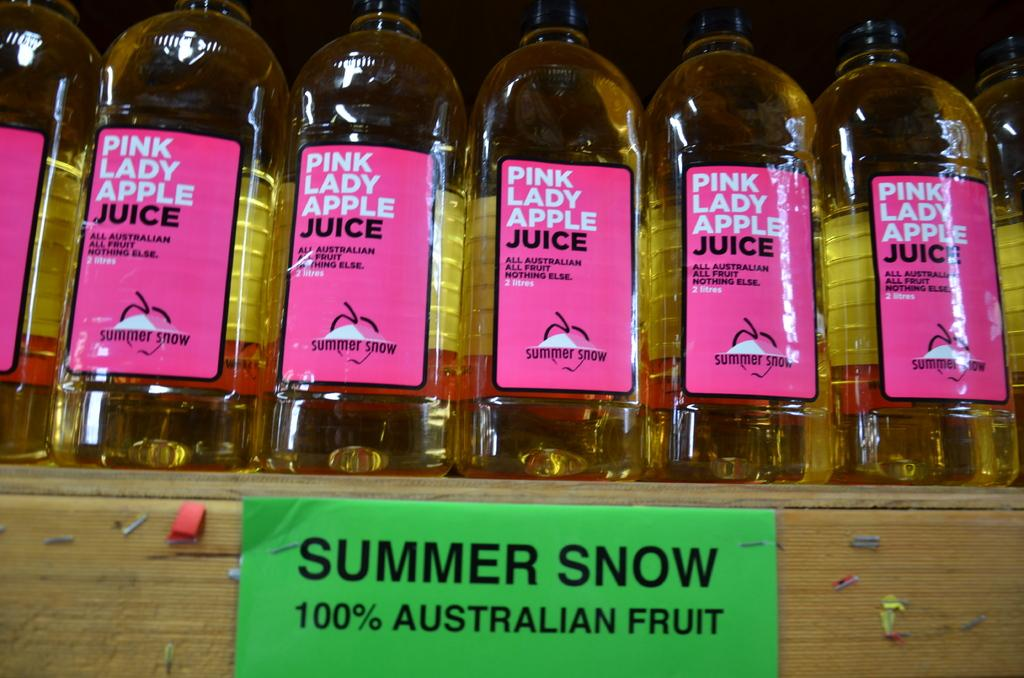What is the main subject of the image? The main subject of the image is a bunch of juice bottles. Can you describe the appearance of the juice bottles? Unfortunately, the appearance of the juice bottles cannot be described without more information. How many juice bottles are in the bunch? The number of juice bottles in the bunch cannot be determined without more information. What rule is being enforced during the rainstorm in the image? There is no rainstorm or rule present in the image; it only features a bunch of juice bottles. 